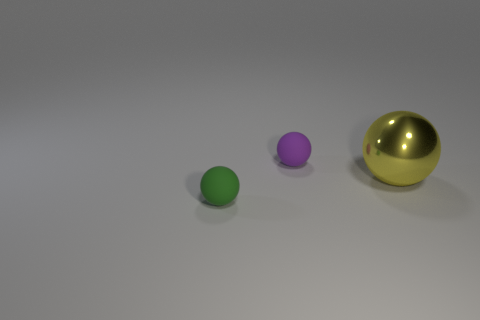Subtract all small purple matte balls. How many balls are left? 2 Add 2 green matte spheres. How many objects exist? 5 Subtract all purple balls. How many balls are left? 2 Subtract 2 balls. How many balls are left? 1 Add 3 tiny purple matte objects. How many tiny purple matte objects are left? 4 Add 3 green matte things. How many green matte things exist? 4 Subtract 0 yellow cubes. How many objects are left? 3 Subtract all cyan balls. Subtract all yellow blocks. How many balls are left? 3 Subtract all purple cylinders. How many purple spheres are left? 1 Subtract all small purple spheres. Subtract all tiny green rubber spheres. How many objects are left? 1 